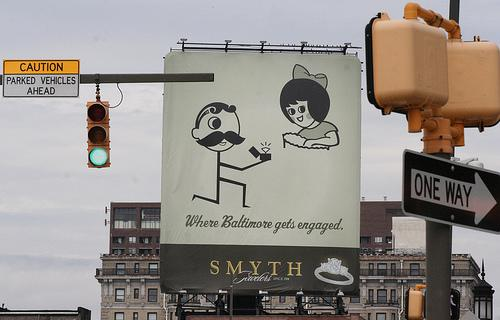Question: what color is the light?
Choices:
A. Green.
B. White.
C. Red.
D. Blue.
Answer with the letter. Answer: A Question: who will see the light?
Choices:
A. People.
B. Everyone.
C. No one.
D. Someone.
Answer with the letter. Answer: A Question: where is the light?
Choices:
A. Over the ad.
B. Under the ad.
C. Next to the ad.
D. Behind the ad.
Answer with the letter. Answer: C 